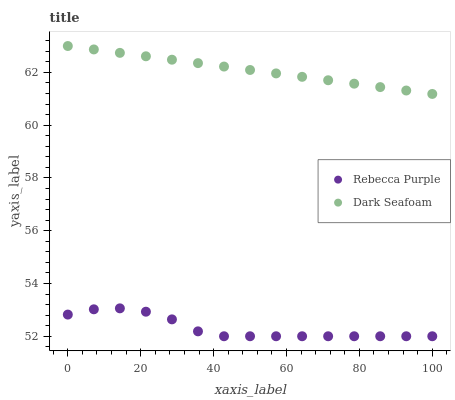Does Rebecca Purple have the minimum area under the curve?
Answer yes or no. Yes. Does Dark Seafoam have the maximum area under the curve?
Answer yes or no. Yes. Does Rebecca Purple have the maximum area under the curve?
Answer yes or no. No. Is Dark Seafoam the smoothest?
Answer yes or no. Yes. Is Rebecca Purple the roughest?
Answer yes or no. Yes. Is Rebecca Purple the smoothest?
Answer yes or no. No. Does Rebecca Purple have the lowest value?
Answer yes or no. Yes. Does Dark Seafoam have the highest value?
Answer yes or no. Yes. Does Rebecca Purple have the highest value?
Answer yes or no. No. Is Rebecca Purple less than Dark Seafoam?
Answer yes or no. Yes. Is Dark Seafoam greater than Rebecca Purple?
Answer yes or no. Yes. Does Rebecca Purple intersect Dark Seafoam?
Answer yes or no. No. 